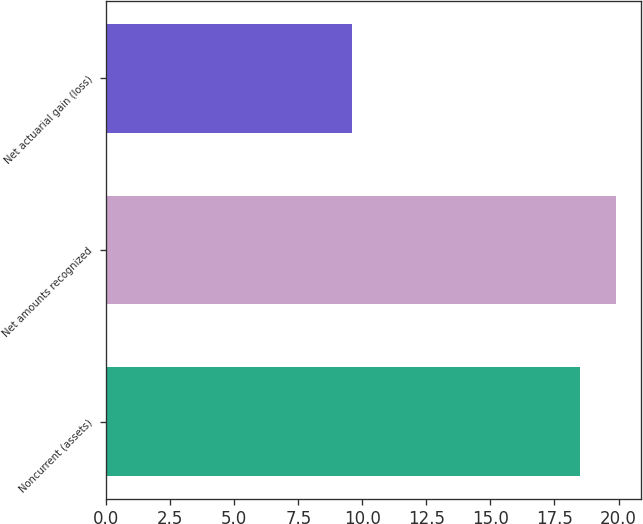Convert chart to OTSL. <chart><loc_0><loc_0><loc_500><loc_500><bar_chart><fcel>Noncurrent (assets)<fcel>Net amounts recognized<fcel>Net actuarial gain (loss)<nl><fcel>18.5<fcel>19.9<fcel>9.6<nl></chart> 